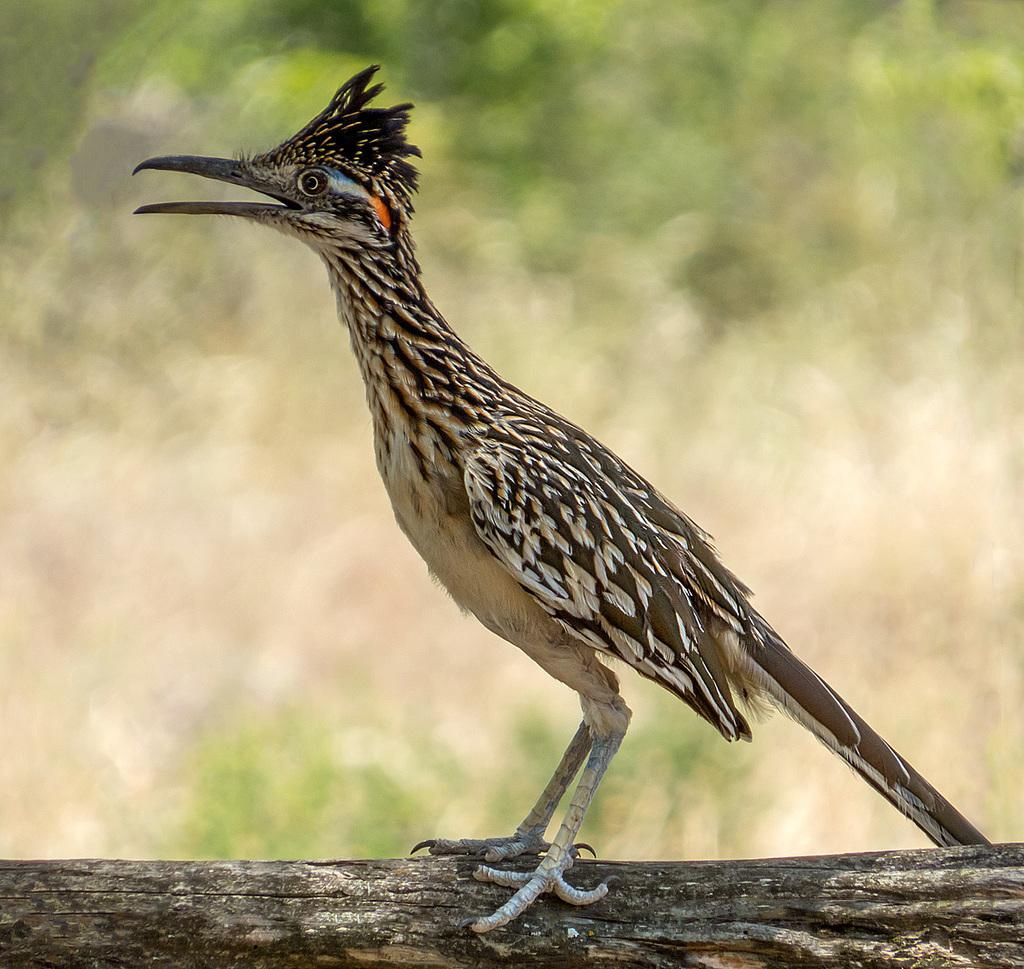What is the main subject of the image? There is a bird in the image. Where is the bird located? The bird is on a piece of wood. What is a distinctive feature of the bird? The bird has a long beak. What color is predominant in the background of the image? The background of the image is green. How is the image affected in the background? The image is blurred in the background. What type of distribution system is depicted in the image? There is no distribution system present in the image; it features a bird on a piece of wood. How many trees are visible in the image? There are no trees visible in the image; it only shows a bird on a piece of wood. 